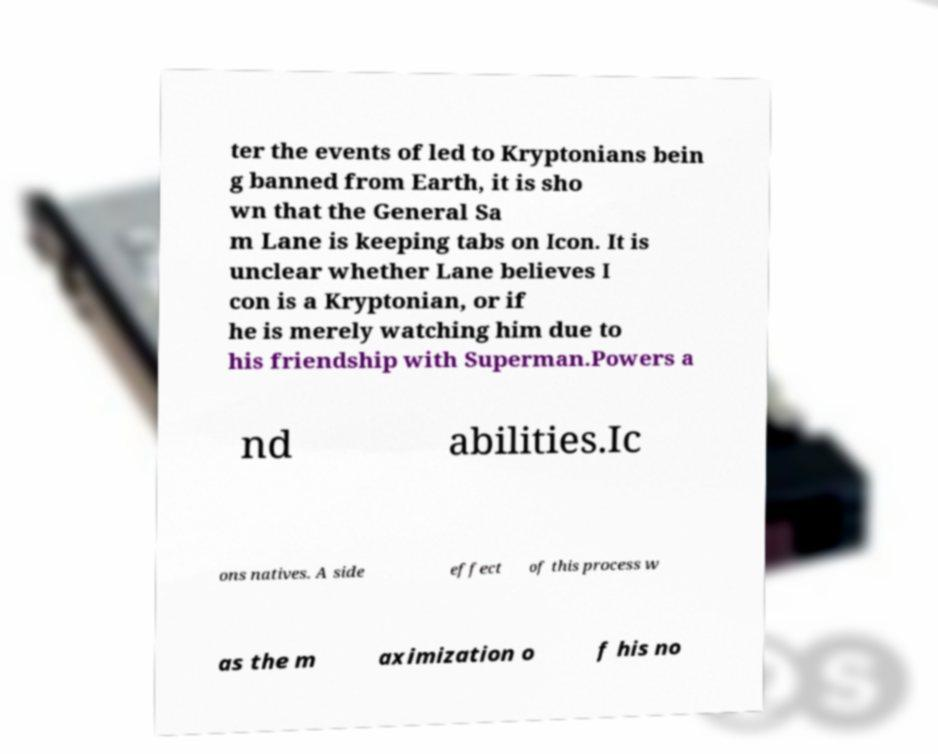There's text embedded in this image that I need extracted. Can you transcribe it verbatim? ter the events of led to Kryptonians bein g banned from Earth, it is sho wn that the General Sa m Lane is keeping tabs on Icon. It is unclear whether Lane believes I con is a Kryptonian, or if he is merely watching him due to his friendship with Superman.Powers a nd abilities.Ic ons natives. A side effect of this process w as the m aximization o f his no 